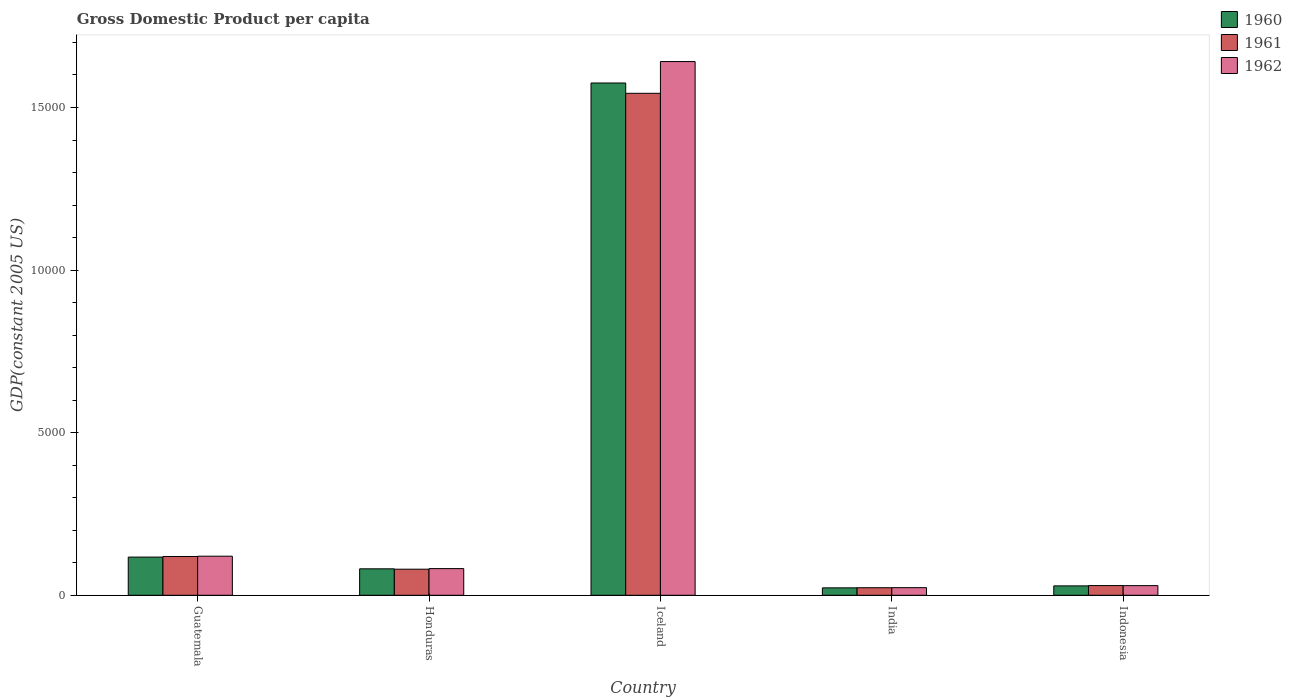How many different coloured bars are there?
Offer a very short reply. 3. Are the number of bars per tick equal to the number of legend labels?
Make the answer very short. Yes. How many bars are there on the 5th tick from the right?
Offer a terse response. 3. What is the label of the 1st group of bars from the left?
Give a very brief answer. Guatemala. What is the GDP per capita in 1962 in Iceland?
Your answer should be very brief. 1.64e+04. Across all countries, what is the maximum GDP per capita in 1960?
Provide a short and direct response. 1.58e+04. Across all countries, what is the minimum GDP per capita in 1960?
Keep it short and to the point. 228.3. What is the total GDP per capita in 1962 in the graph?
Ensure brevity in your answer.  1.90e+04. What is the difference between the GDP per capita in 1961 in Guatemala and that in India?
Give a very brief answer. 960.28. What is the difference between the GDP per capita in 1961 in India and the GDP per capita in 1962 in Indonesia?
Your answer should be compact. -64.23. What is the average GDP per capita in 1960 per country?
Give a very brief answer. 3651.74. What is the difference between the GDP per capita of/in 1961 and GDP per capita of/in 1962 in Indonesia?
Offer a very short reply. 2.25. In how many countries, is the GDP per capita in 1961 greater than 11000 US$?
Make the answer very short. 1. What is the ratio of the GDP per capita in 1962 in Guatemala to that in Iceland?
Ensure brevity in your answer.  0.07. What is the difference between the highest and the second highest GDP per capita in 1961?
Ensure brevity in your answer.  390.64. What is the difference between the highest and the lowest GDP per capita in 1960?
Provide a succinct answer. 1.55e+04. Is the sum of the GDP per capita in 1962 in Guatemala and Iceland greater than the maximum GDP per capita in 1960 across all countries?
Offer a very short reply. Yes. Is it the case that in every country, the sum of the GDP per capita in 1960 and GDP per capita in 1962 is greater than the GDP per capita in 1961?
Give a very brief answer. Yes. How many bars are there?
Give a very brief answer. 15. Are all the bars in the graph horizontal?
Keep it short and to the point. No. How many countries are there in the graph?
Your answer should be compact. 5. Are the values on the major ticks of Y-axis written in scientific E-notation?
Your answer should be very brief. No. Does the graph contain any zero values?
Ensure brevity in your answer.  No. How are the legend labels stacked?
Your response must be concise. Vertical. What is the title of the graph?
Keep it short and to the point. Gross Domestic Product per capita. Does "1984" appear as one of the legend labels in the graph?
Your answer should be compact. No. What is the label or title of the X-axis?
Offer a terse response. Country. What is the label or title of the Y-axis?
Provide a short and direct response. GDP(constant 2005 US). What is the GDP(constant 2005 US) of 1960 in Guatemala?
Give a very brief answer. 1174.44. What is the GDP(constant 2005 US) in 1961 in Guatemala?
Keep it short and to the point. 1192.42. What is the GDP(constant 2005 US) of 1962 in Guatemala?
Make the answer very short. 1201.57. What is the GDP(constant 2005 US) in 1960 in Honduras?
Offer a terse response. 813.41. What is the GDP(constant 2005 US) in 1961 in Honduras?
Your answer should be very brief. 801.77. What is the GDP(constant 2005 US) of 1962 in Honduras?
Provide a succinct answer. 820.2. What is the GDP(constant 2005 US) in 1960 in Iceland?
Your answer should be very brief. 1.58e+04. What is the GDP(constant 2005 US) of 1961 in Iceland?
Offer a terse response. 1.54e+04. What is the GDP(constant 2005 US) in 1962 in Iceland?
Make the answer very short. 1.64e+04. What is the GDP(constant 2005 US) of 1960 in India?
Provide a succinct answer. 228.3. What is the GDP(constant 2005 US) of 1961 in India?
Give a very brief answer. 232.14. What is the GDP(constant 2005 US) in 1962 in India?
Offer a terse response. 234.17. What is the GDP(constant 2005 US) of 1960 in Indonesia?
Your answer should be compact. 288.96. What is the GDP(constant 2005 US) of 1961 in Indonesia?
Your answer should be compact. 298.63. What is the GDP(constant 2005 US) in 1962 in Indonesia?
Offer a terse response. 296.37. Across all countries, what is the maximum GDP(constant 2005 US) in 1960?
Keep it short and to the point. 1.58e+04. Across all countries, what is the maximum GDP(constant 2005 US) of 1961?
Give a very brief answer. 1.54e+04. Across all countries, what is the maximum GDP(constant 2005 US) in 1962?
Ensure brevity in your answer.  1.64e+04. Across all countries, what is the minimum GDP(constant 2005 US) of 1960?
Ensure brevity in your answer.  228.3. Across all countries, what is the minimum GDP(constant 2005 US) of 1961?
Offer a terse response. 232.14. Across all countries, what is the minimum GDP(constant 2005 US) of 1962?
Provide a succinct answer. 234.17. What is the total GDP(constant 2005 US) in 1960 in the graph?
Offer a very short reply. 1.83e+04. What is the total GDP(constant 2005 US) in 1961 in the graph?
Your answer should be compact. 1.80e+04. What is the total GDP(constant 2005 US) of 1962 in the graph?
Ensure brevity in your answer.  1.90e+04. What is the difference between the GDP(constant 2005 US) in 1960 in Guatemala and that in Honduras?
Keep it short and to the point. 361.03. What is the difference between the GDP(constant 2005 US) in 1961 in Guatemala and that in Honduras?
Provide a succinct answer. 390.64. What is the difference between the GDP(constant 2005 US) of 1962 in Guatemala and that in Honduras?
Your answer should be very brief. 381.38. What is the difference between the GDP(constant 2005 US) of 1960 in Guatemala and that in Iceland?
Your answer should be very brief. -1.46e+04. What is the difference between the GDP(constant 2005 US) of 1961 in Guatemala and that in Iceland?
Give a very brief answer. -1.42e+04. What is the difference between the GDP(constant 2005 US) in 1962 in Guatemala and that in Iceland?
Your response must be concise. -1.52e+04. What is the difference between the GDP(constant 2005 US) in 1960 in Guatemala and that in India?
Provide a short and direct response. 946.14. What is the difference between the GDP(constant 2005 US) of 1961 in Guatemala and that in India?
Keep it short and to the point. 960.28. What is the difference between the GDP(constant 2005 US) in 1962 in Guatemala and that in India?
Your answer should be very brief. 967.41. What is the difference between the GDP(constant 2005 US) in 1960 in Guatemala and that in Indonesia?
Offer a terse response. 885.48. What is the difference between the GDP(constant 2005 US) of 1961 in Guatemala and that in Indonesia?
Offer a very short reply. 893.79. What is the difference between the GDP(constant 2005 US) of 1962 in Guatemala and that in Indonesia?
Your response must be concise. 905.2. What is the difference between the GDP(constant 2005 US) in 1960 in Honduras and that in Iceland?
Make the answer very short. -1.49e+04. What is the difference between the GDP(constant 2005 US) of 1961 in Honduras and that in Iceland?
Keep it short and to the point. -1.46e+04. What is the difference between the GDP(constant 2005 US) of 1962 in Honduras and that in Iceland?
Give a very brief answer. -1.56e+04. What is the difference between the GDP(constant 2005 US) of 1960 in Honduras and that in India?
Provide a short and direct response. 585.1. What is the difference between the GDP(constant 2005 US) of 1961 in Honduras and that in India?
Make the answer very short. 569.63. What is the difference between the GDP(constant 2005 US) of 1962 in Honduras and that in India?
Your response must be concise. 586.03. What is the difference between the GDP(constant 2005 US) of 1960 in Honduras and that in Indonesia?
Offer a terse response. 524.45. What is the difference between the GDP(constant 2005 US) in 1961 in Honduras and that in Indonesia?
Keep it short and to the point. 503.15. What is the difference between the GDP(constant 2005 US) of 1962 in Honduras and that in Indonesia?
Offer a very short reply. 523.83. What is the difference between the GDP(constant 2005 US) of 1960 in Iceland and that in India?
Offer a very short reply. 1.55e+04. What is the difference between the GDP(constant 2005 US) of 1961 in Iceland and that in India?
Offer a very short reply. 1.52e+04. What is the difference between the GDP(constant 2005 US) in 1962 in Iceland and that in India?
Provide a short and direct response. 1.62e+04. What is the difference between the GDP(constant 2005 US) of 1960 in Iceland and that in Indonesia?
Offer a very short reply. 1.55e+04. What is the difference between the GDP(constant 2005 US) in 1961 in Iceland and that in Indonesia?
Provide a short and direct response. 1.51e+04. What is the difference between the GDP(constant 2005 US) in 1962 in Iceland and that in Indonesia?
Your answer should be very brief. 1.61e+04. What is the difference between the GDP(constant 2005 US) of 1960 in India and that in Indonesia?
Offer a very short reply. -60.66. What is the difference between the GDP(constant 2005 US) in 1961 in India and that in Indonesia?
Your response must be concise. -66.48. What is the difference between the GDP(constant 2005 US) in 1962 in India and that in Indonesia?
Provide a short and direct response. -62.21. What is the difference between the GDP(constant 2005 US) of 1960 in Guatemala and the GDP(constant 2005 US) of 1961 in Honduras?
Offer a very short reply. 372.67. What is the difference between the GDP(constant 2005 US) in 1960 in Guatemala and the GDP(constant 2005 US) in 1962 in Honduras?
Offer a terse response. 354.24. What is the difference between the GDP(constant 2005 US) of 1961 in Guatemala and the GDP(constant 2005 US) of 1962 in Honduras?
Keep it short and to the point. 372.22. What is the difference between the GDP(constant 2005 US) of 1960 in Guatemala and the GDP(constant 2005 US) of 1961 in Iceland?
Your answer should be very brief. -1.43e+04. What is the difference between the GDP(constant 2005 US) of 1960 in Guatemala and the GDP(constant 2005 US) of 1962 in Iceland?
Make the answer very short. -1.52e+04. What is the difference between the GDP(constant 2005 US) in 1961 in Guatemala and the GDP(constant 2005 US) in 1962 in Iceland?
Your response must be concise. -1.52e+04. What is the difference between the GDP(constant 2005 US) of 1960 in Guatemala and the GDP(constant 2005 US) of 1961 in India?
Provide a succinct answer. 942.3. What is the difference between the GDP(constant 2005 US) in 1960 in Guatemala and the GDP(constant 2005 US) in 1962 in India?
Your answer should be very brief. 940.28. What is the difference between the GDP(constant 2005 US) of 1961 in Guatemala and the GDP(constant 2005 US) of 1962 in India?
Give a very brief answer. 958.25. What is the difference between the GDP(constant 2005 US) of 1960 in Guatemala and the GDP(constant 2005 US) of 1961 in Indonesia?
Your response must be concise. 875.82. What is the difference between the GDP(constant 2005 US) in 1960 in Guatemala and the GDP(constant 2005 US) in 1962 in Indonesia?
Your answer should be very brief. 878.07. What is the difference between the GDP(constant 2005 US) of 1961 in Guatemala and the GDP(constant 2005 US) of 1962 in Indonesia?
Ensure brevity in your answer.  896.04. What is the difference between the GDP(constant 2005 US) in 1960 in Honduras and the GDP(constant 2005 US) in 1961 in Iceland?
Your answer should be very brief. -1.46e+04. What is the difference between the GDP(constant 2005 US) in 1960 in Honduras and the GDP(constant 2005 US) in 1962 in Iceland?
Your answer should be very brief. -1.56e+04. What is the difference between the GDP(constant 2005 US) in 1961 in Honduras and the GDP(constant 2005 US) in 1962 in Iceland?
Make the answer very short. -1.56e+04. What is the difference between the GDP(constant 2005 US) of 1960 in Honduras and the GDP(constant 2005 US) of 1961 in India?
Your answer should be compact. 581.27. What is the difference between the GDP(constant 2005 US) of 1960 in Honduras and the GDP(constant 2005 US) of 1962 in India?
Your answer should be very brief. 579.24. What is the difference between the GDP(constant 2005 US) in 1961 in Honduras and the GDP(constant 2005 US) in 1962 in India?
Your answer should be compact. 567.61. What is the difference between the GDP(constant 2005 US) of 1960 in Honduras and the GDP(constant 2005 US) of 1961 in Indonesia?
Make the answer very short. 514.78. What is the difference between the GDP(constant 2005 US) in 1960 in Honduras and the GDP(constant 2005 US) in 1962 in Indonesia?
Your response must be concise. 517.04. What is the difference between the GDP(constant 2005 US) in 1961 in Honduras and the GDP(constant 2005 US) in 1962 in Indonesia?
Give a very brief answer. 505.4. What is the difference between the GDP(constant 2005 US) of 1960 in Iceland and the GDP(constant 2005 US) of 1961 in India?
Provide a short and direct response. 1.55e+04. What is the difference between the GDP(constant 2005 US) of 1960 in Iceland and the GDP(constant 2005 US) of 1962 in India?
Give a very brief answer. 1.55e+04. What is the difference between the GDP(constant 2005 US) of 1961 in Iceland and the GDP(constant 2005 US) of 1962 in India?
Make the answer very short. 1.52e+04. What is the difference between the GDP(constant 2005 US) in 1960 in Iceland and the GDP(constant 2005 US) in 1961 in Indonesia?
Make the answer very short. 1.55e+04. What is the difference between the GDP(constant 2005 US) of 1960 in Iceland and the GDP(constant 2005 US) of 1962 in Indonesia?
Offer a terse response. 1.55e+04. What is the difference between the GDP(constant 2005 US) of 1961 in Iceland and the GDP(constant 2005 US) of 1962 in Indonesia?
Provide a short and direct response. 1.51e+04. What is the difference between the GDP(constant 2005 US) in 1960 in India and the GDP(constant 2005 US) in 1961 in Indonesia?
Provide a short and direct response. -70.32. What is the difference between the GDP(constant 2005 US) in 1960 in India and the GDP(constant 2005 US) in 1962 in Indonesia?
Provide a succinct answer. -68.07. What is the difference between the GDP(constant 2005 US) in 1961 in India and the GDP(constant 2005 US) in 1962 in Indonesia?
Provide a short and direct response. -64.23. What is the average GDP(constant 2005 US) of 1960 per country?
Give a very brief answer. 3651.74. What is the average GDP(constant 2005 US) in 1961 per country?
Your answer should be very brief. 3592.29. What is the average GDP(constant 2005 US) in 1962 per country?
Provide a succinct answer. 3793.03. What is the difference between the GDP(constant 2005 US) of 1960 and GDP(constant 2005 US) of 1961 in Guatemala?
Your answer should be very brief. -17.97. What is the difference between the GDP(constant 2005 US) in 1960 and GDP(constant 2005 US) in 1962 in Guatemala?
Ensure brevity in your answer.  -27.13. What is the difference between the GDP(constant 2005 US) in 1961 and GDP(constant 2005 US) in 1962 in Guatemala?
Your response must be concise. -9.16. What is the difference between the GDP(constant 2005 US) of 1960 and GDP(constant 2005 US) of 1961 in Honduras?
Give a very brief answer. 11.63. What is the difference between the GDP(constant 2005 US) of 1960 and GDP(constant 2005 US) of 1962 in Honduras?
Provide a short and direct response. -6.79. What is the difference between the GDP(constant 2005 US) in 1961 and GDP(constant 2005 US) in 1962 in Honduras?
Your answer should be compact. -18.42. What is the difference between the GDP(constant 2005 US) in 1960 and GDP(constant 2005 US) in 1961 in Iceland?
Make the answer very short. 317.1. What is the difference between the GDP(constant 2005 US) in 1960 and GDP(constant 2005 US) in 1962 in Iceland?
Your answer should be compact. -659.22. What is the difference between the GDP(constant 2005 US) in 1961 and GDP(constant 2005 US) in 1962 in Iceland?
Offer a very short reply. -976.32. What is the difference between the GDP(constant 2005 US) of 1960 and GDP(constant 2005 US) of 1961 in India?
Make the answer very short. -3.84. What is the difference between the GDP(constant 2005 US) of 1960 and GDP(constant 2005 US) of 1962 in India?
Provide a succinct answer. -5.86. What is the difference between the GDP(constant 2005 US) of 1961 and GDP(constant 2005 US) of 1962 in India?
Your answer should be very brief. -2.02. What is the difference between the GDP(constant 2005 US) of 1960 and GDP(constant 2005 US) of 1961 in Indonesia?
Your answer should be very brief. -9.66. What is the difference between the GDP(constant 2005 US) of 1960 and GDP(constant 2005 US) of 1962 in Indonesia?
Ensure brevity in your answer.  -7.41. What is the difference between the GDP(constant 2005 US) of 1961 and GDP(constant 2005 US) of 1962 in Indonesia?
Offer a terse response. 2.25. What is the ratio of the GDP(constant 2005 US) in 1960 in Guatemala to that in Honduras?
Give a very brief answer. 1.44. What is the ratio of the GDP(constant 2005 US) of 1961 in Guatemala to that in Honduras?
Ensure brevity in your answer.  1.49. What is the ratio of the GDP(constant 2005 US) in 1962 in Guatemala to that in Honduras?
Keep it short and to the point. 1.47. What is the ratio of the GDP(constant 2005 US) of 1960 in Guatemala to that in Iceland?
Your response must be concise. 0.07. What is the ratio of the GDP(constant 2005 US) of 1961 in Guatemala to that in Iceland?
Your response must be concise. 0.08. What is the ratio of the GDP(constant 2005 US) of 1962 in Guatemala to that in Iceland?
Offer a very short reply. 0.07. What is the ratio of the GDP(constant 2005 US) of 1960 in Guatemala to that in India?
Your response must be concise. 5.14. What is the ratio of the GDP(constant 2005 US) of 1961 in Guatemala to that in India?
Provide a succinct answer. 5.14. What is the ratio of the GDP(constant 2005 US) of 1962 in Guatemala to that in India?
Make the answer very short. 5.13. What is the ratio of the GDP(constant 2005 US) of 1960 in Guatemala to that in Indonesia?
Provide a short and direct response. 4.06. What is the ratio of the GDP(constant 2005 US) of 1961 in Guatemala to that in Indonesia?
Make the answer very short. 3.99. What is the ratio of the GDP(constant 2005 US) in 1962 in Guatemala to that in Indonesia?
Give a very brief answer. 4.05. What is the ratio of the GDP(constant 2005 US) in 1960 in Honduras to that in Iceland?
Offer a terse response. 0.05. What is the ratio of the GDP(constant 2005 US) of 1961 in Honduras to that in Iceland?
Offer a very short reply. 0.05. What is the ratio of the GDP(constant 2005 US) in 1960 in Honduras to that in India?
Provide a short and direct response. 3.56. What is the ratio of the GDP(constant 2005 US) of 1961 in Honduras to that in India?
Give a very brief answer. 3.45. What is the ratio of the GDP(constant 2005 US) in 1962 in Honduras to that in India?
Your answer should be very brief. 3.5. What is the ratio of the GDP(constant 2005 US) in 1960 in Honduras to that in Indonesia?
Your answer should be compact. 2.81. What is the ratio of the GDP(constant 2005 US) of 1961 in Honduras to that in Indonesia?
Offer a very short reply. 2.68. What is the ratio of the GDP(constant 2005 US) of 1962 in Honduras to that in Indonesia?
Your answer should be compact. 2.77. What is the ratio of the GDP(constant 2005 US) in 1960 in Iceland to that in India?
Your response must be concise. 69. What is the ratio of the GDP(constant 2005 US) of 1961 in Iceland to that in India?
Your answer should be very brief. 66.5. What is the ratio of the GDP(constant 2005 US) in 1962 in Iceland to that in India?
Offer a terse response. 70.09. What is the ratio of the GDP(constant 2005 US) of 1960 in Iceland to that in Indonesia?
Offer a terse response. 54.52. What is the ratio of the GDP(constant 2005 US) of 1961 in Iceland to that in Indonesia?
Your response must be concise. 51.69. What is the ratio of the GDP(constant 2005 US) in 1962 in Iceland to that in Indonesia?
Offer a very short reply. 55.38. What is the ratio of the GDP(constant 2005 US) in 1960 in India to that in Indonesia?
Provide a succinct answer. 0.79. What is the ratio of the GDP(constant 2005 US) in 1961 in India to that in Indonesia?
Make the answer very short. 0.78. What is the ratio of the GDP(constant 2005 US) of 1962 in India to that in Indonesia?
Keep it short and to the point. 0.79. What is the difference between the highest and the second highest GDP(constant 2005 US) of 1960?
Keep it short and to the point. 1.46e+04. What is the difference between the highest and the second highest GDP(constant 2005 US) of 1961?
Your answer should be very brief. 1.42e+04. What is the difference between the highest and the second highest GDP(constant 2005 US) of 1962?
Your answer should be compact. 1.52e+04. What is the difference between the highest and the lowest GDP(constant 2005 US) in 1960?
Your answer should be very brief. 1.55e+04. What is the difference between the highest and the lowest GDP(constant 2005 US) in 1961?
Your response must be concise. 1.52e+04. What is the difference between the highest and the lowest GDP(constant 2005 US) of 1962?
Provide a succinct answer. 1.62e+04. 